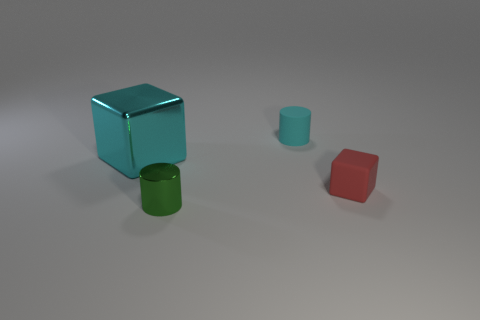The thing that is the same color as the rubber cylinder is what size?
Your response must be concise. Large. What material is the tiny thing that is the same color as the big metallic block?
Your answer should be very brief. Rubber. Are the small cylinder that is in front of the cyan metallic cube and the object on the left side of the tiny shiny cylinder made of the same material?
Offer a terse response. Yes. Are there more tiny green cylinders than gray rubber objects?
Offer a very short reply. Yes. What is the color of the rubber thing that is right of the tiny thing that is behind the metallic thing behind the red thing?
Keep it short and to the point. Red. Is the color of the tiny cylinder in front of the tiny red matte cube the same as the block right of the tiny shiny object?
Provide a short and direct response. No. What number of tiny red cubes are on the left side of the small red object that is right of the cyan cube?
Keep it short and to the point. 0. Is there a large brown matte thing?
Give a very brief answer. No. How many other objects are there of the same color as the tiny matte cube?
Provide a short and direct response. 0. Are there fewer red rubber cylinders than tiny things?
Ensure brevity in your answer.  Yes. 